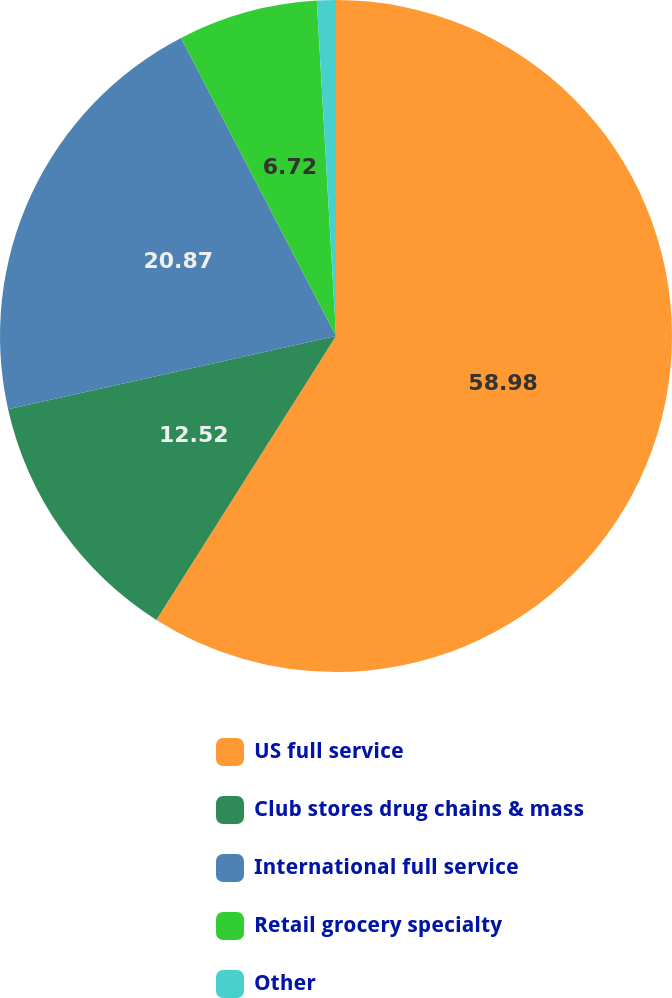Convert chart. <chart><loc_0><loc_0><loc_500><loc_500><pie_chart><fcel>US full service<fcel>Club stores drug chains & mass<fcel>International full service<fcel>Retail grocery specialty<fcel>Other<nl><fcel>58.98%<fcel>12.52%<fcel>20.87%<fcel>6.72%<fcel>0.91%<nl></chart> 